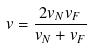Convert formula to latex. <formula><loc_0><loc_0><loc_500><loc_500>v = \frac { 2 v _ { N } v _ { F } } { v _ { N } + v _ { F } }</formula> 